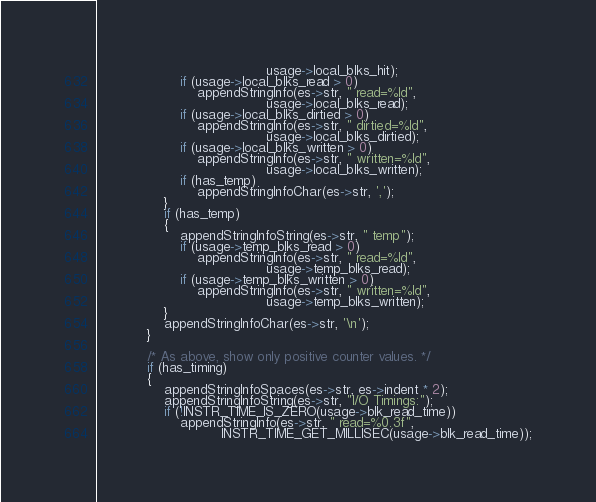<code> <loc_0><loc_0><loc_500><loc_500><_C_>										 usage->local_blks_hit);
					if (usage->local_blks_read > 0)
						appendStringInfo(es->str, " read=%ld",
										 usage->local_blks_read);
					if (usage->local_blks_dirtied > 0)
						appendStringInfo(es->str, " dirtied=%ld",
										 usage->local_blks_dirtied);
					if (usage->local_blks_written > 0)
						appendStringInfo(es->str, " written=%ld",
										 usage->local_blks_written);
					if (has_temp)
						appendStringInfoChar(es->str, ',');
				}
				if (has_temp)
				{
					appendStringInfoString(es->str, " temp");
					if (usage->temp_blks_read > 0)
						appendStringInfo(es->str, " read=%ld",
										 usage->temp_blks_read);
					if (usage->temp_blks_written > 0)
						appendStringInfo(es->str, " written=%ld",
										 usage->temp_blks_written);
				}
				appendStringInfoChar(es->str, '\n');
			}

			/* As above, show only positive counter values. */
			if (has_timing)
			{
				appendStringInfoSpaces(es->str, es->indent * 2);
				appendStringInfoString(es->str, "I/O Timings:");
				if (!INSTR_TIME_IS_ZERO(usage->blk_read_time))
					appendStringInfo(es->str, " read=%0.3f",
							  INSTR_TIME_GET_MILLISEC(usage->blk_read_time));</code> 